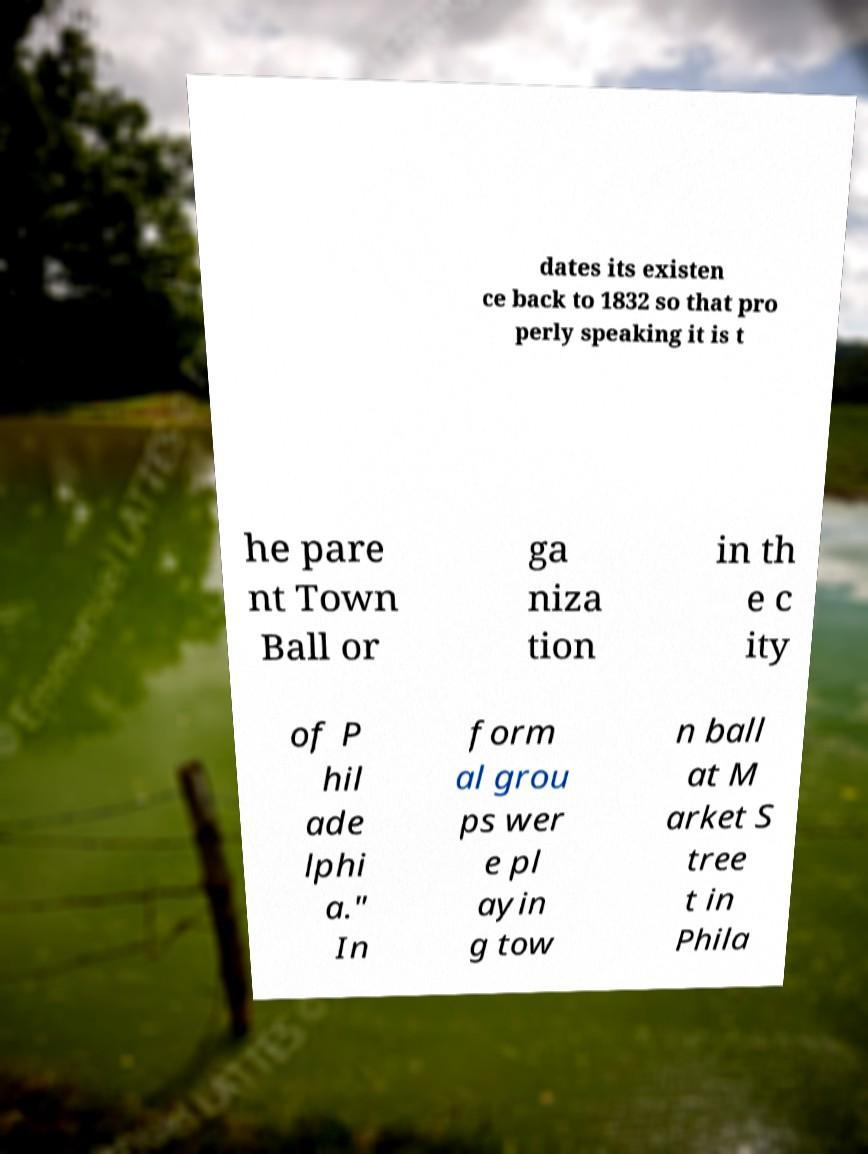Could you extract and type out the text from this image? dates its existen ce back to 1832 so that pro perly speaking it is t he pare nt Town Ball or ga niza tion in th e c ity of P hil ade lphi a." In form al grou ps wer e pl ayin g tow n ball at M arket S tree t in Phila 